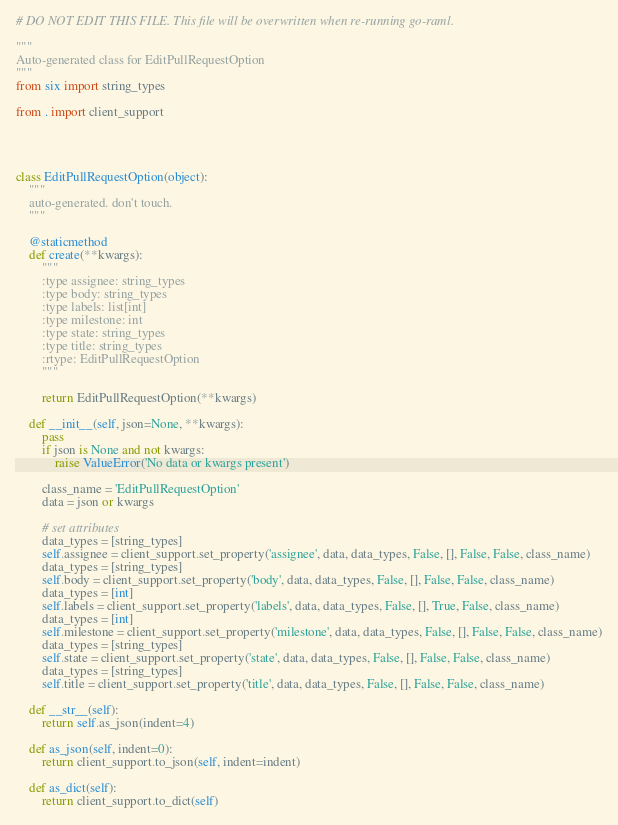Convert code to text. <code><loc_0><loc_0><loc_500><loc_500><_Python_># DO NOT EDIT THIS FILE. This file will be overwritten when re-running go-raml.

"""
Auto-generated class for EditPullRequestOption
"""
from six import string_types

from . import client_support




class EditPullRequestOption(object):
    """
    auto-generated. don't touch.
    """

    @staticmethod
    def create(**kwargs):
        """
        :type assignee: string_types
        :type body: string_types
        :type labels: list[int]
        :type milestone: int
        :type state: string_types
        :type title: string_types
        :rtype: EditPullRequestOption
        """

        return EditPullRequestOption(**kwargs)

    def __init__(self, json=None, **kwargs):
        pass
        if json is None and not kwargs:
            raise ValueError('No data or kwargs present')

        class_name = 'EditPullRequestOption'
        data = json or kwargs

        # set attributes
        data_types = [string_types]
        self.assignee = client_support.set_property('assignee', data, data_types, False, [], False, False, class_name)
        data_types = [string_types]
        self.body = client_support.set_property('body', data, data_types, False, [], False, False, class_name)
        data_types = [int]
        self.labels = client_support.set_property('labels', data, data_types, False, [], True, False, class_name)
        data_types = [int]
        self.milestone = client_support.set_property('milestone', data, data_types, False, [], False, False, class_name)
        data_types = [string_types]
        self.state = client_support.set_property('state', data, data_types, False, [], False, False, class_name)
        data_types = [string_types]
        self.title = client_support.set_property('title', data, data_types, False, [], False, False, class_name)

    def __str__(self):
        return self.as_json(indent=4)

    def as_json(self, indent=0):
        return client_support.to_json(self, indent=indent)

    def as_dict(self):
        return client_support.to_dict(self)
</code> 